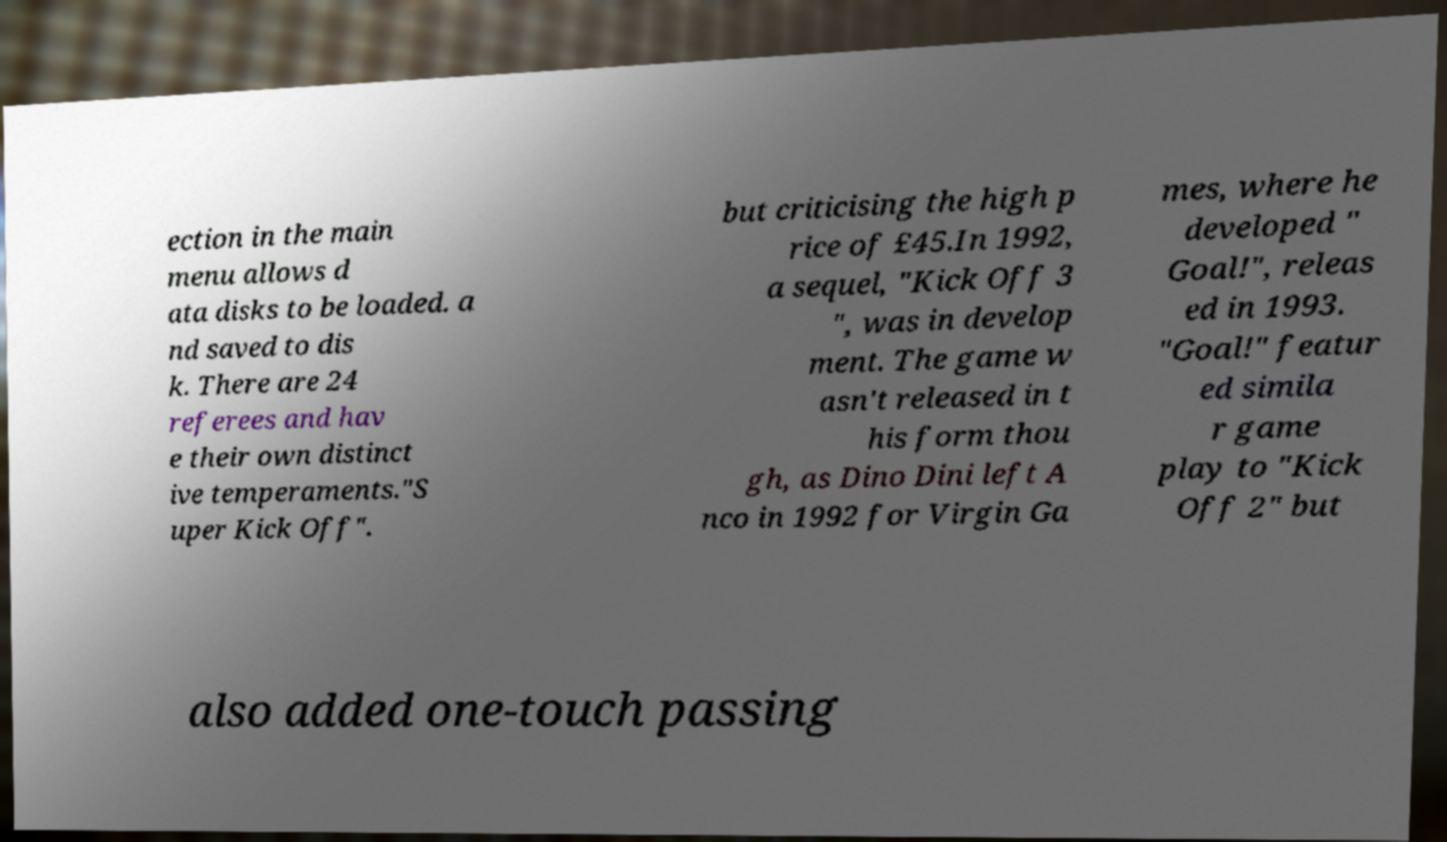Can you accurately transcribe the text from the provided image for me? ection in the main menu allows d ata disks to be loaded. a nd saved to dis k. There are 24 referees and hav e their own distinct ive temperaments."S uper Kick Off". but criticising the high p rice of £45.In 1992, a sequel, "Kick Off 3 ", was in develop ment. The game w asn't released in t his form thou gh, as Dino Dini left A nco in 1992 for Virgin Ga mes, where he developed " Goal!", releas ed in 1993. "Goal!" featur ed simila r game play to "Kick Off 2" but also added one-touch passing 